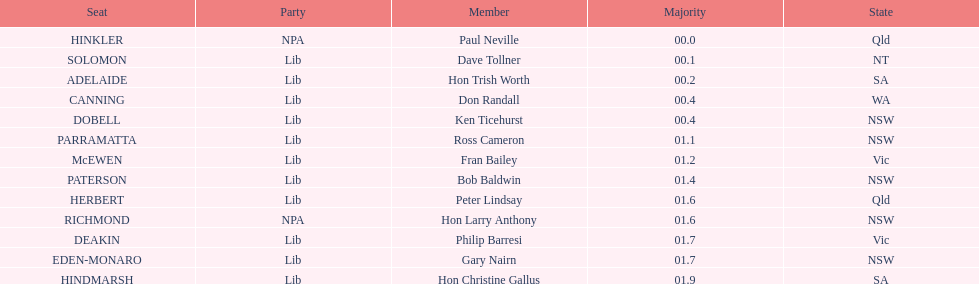What member comes next after hon trish worth? Don Randall. 